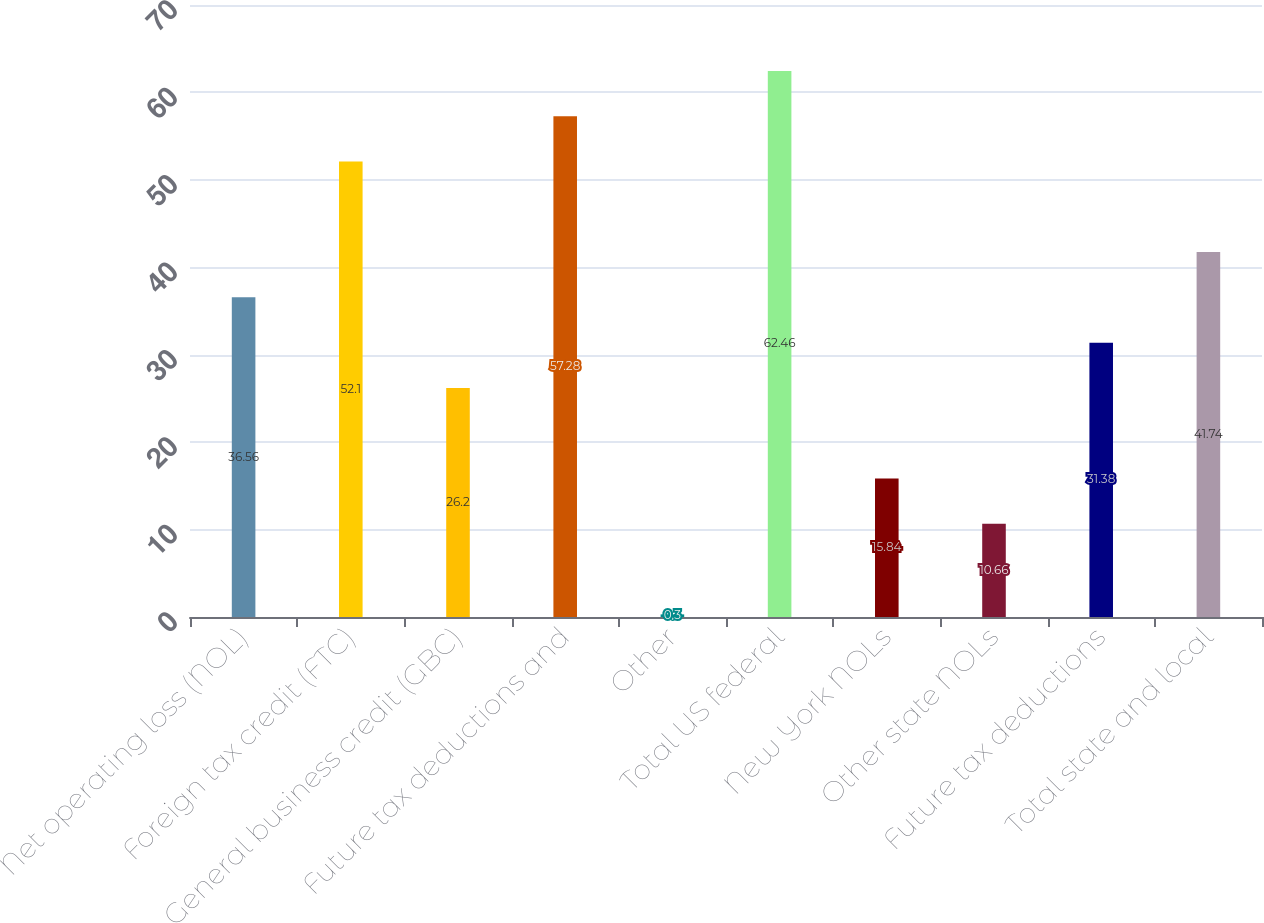<chart> <loc_0><loc_0><loc_500><loc_500><bar_chart><fcel>Net operating loss (NOL)<fcel>Foreign tax credit (FTC)<fcel>General business credit (GBC)<fcel>Future tax deductions and<fcel>Other<fcel>Total US federal<fcel>New York NOLs<fcel>Other state NOLs<fcel>Future tax deductions<fcel>Total state and local<nl><fcel>36.56<fcel>52.1<fcel>26.2<fcel>57.28<fcel>0.3<fcel>62.46<fcel>15.84<fcel>10.66<fcel>31.38<fcel>41.74<nl></chart> 